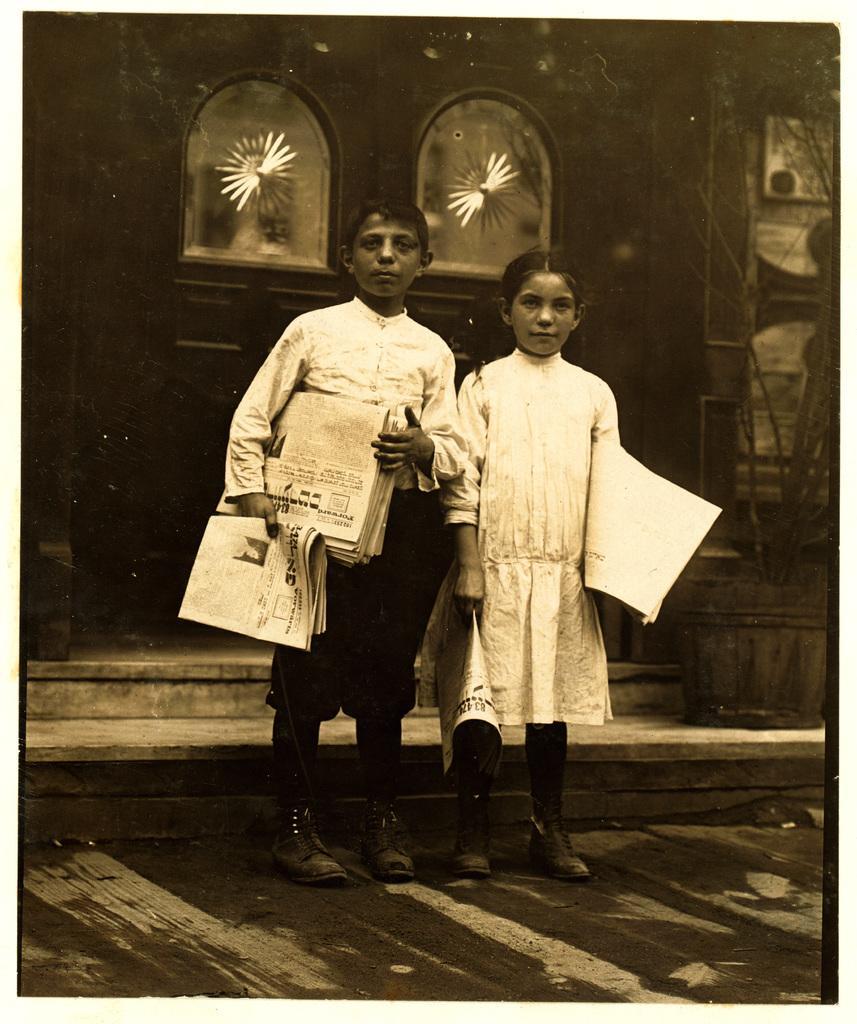Could you give a brief overview of what you see in this image? In this image there are two children holding papers on the road, behind there is a door of the building, a plant in the flower pot. 